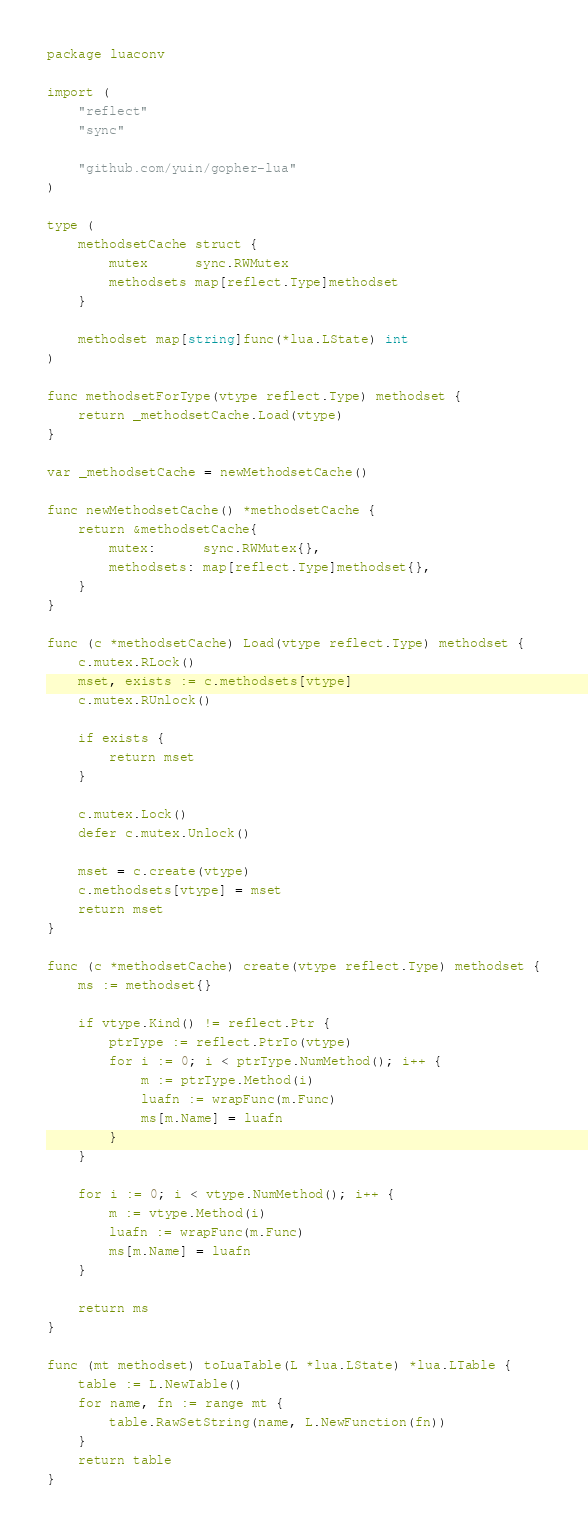<code> <loc_0><loc_0><loc_500><loc_500><_Go_>package luaconv

import (
	"reflect"
	"sync"

	"github.com/yuin/gopher-lua"
)

type (
	methodsetCache struct {
		mutex      sync.RWMutex
		methodsets map[reflect.Type]methodset
	}

	methodset map[string]func(*lua.LState) int
)

func methodsetForType(vtype reflect.Type) methodset {
	return _methodsetCache.Load(vtype)
}

var _methodsetCache = newMethodsetCache()

func newMethodsetCache() *methodsetCache {
	return &methodsetCache{
		mutex:      sync.RWMutex{},
		methodsets: map[reflect.Type]methodset{},
	}
}

func (c *methodsetCache) Load(vtype reflect.Type) methodset {
	c.mutex.RLock()
	mset, exists := c.methodsets[vtype]
	c.mutex.RUnlock()

	if exists {
		return mset
	}

	c.mutex.Lock()
	defer c.mutex.Unlock()

	mset = c.create(vtype)
	c.methodsets[vtype] = mset
	return mset
}

func (c *methodsetCache) create(vtype reflect.Type) methodset {
	ms := methodset{}

	if vtype.Kind() != reflect.Ptr {
		ptrType := reflect.PtrTo(vtype)
		for i := 0; i < ptrType.NumMethod(); i++ {
			m := ptrType.Method(i)
			luafn := wrapFunc(m.Func)
			ms[m.Name] = luafn
		}
	}

	for i := 0; i < vtype.NumMethod(); i++ {
		m := vtype.Method(i)
		luafn := wrapFunc(m.Func)
		ms[m.Name] = luafn
	}

	return ms
}

func (mt methodset) toLuaTable(L *lua.LState) *lua.LTable {
	table := L.NewTable()
	for name, fn := range mt {
		table.RawSetString(name, L.NewFunction(fn))
	}
	return table
}
</code> 